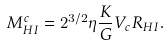<formula> <loc_0><loc_0><loc_500><loc_500>M ^ { c } _ { H I } = 2 ^ { 3 / 2 } \eta \frac { K } { G } V _ { c } R _ { H I } .</formula> 